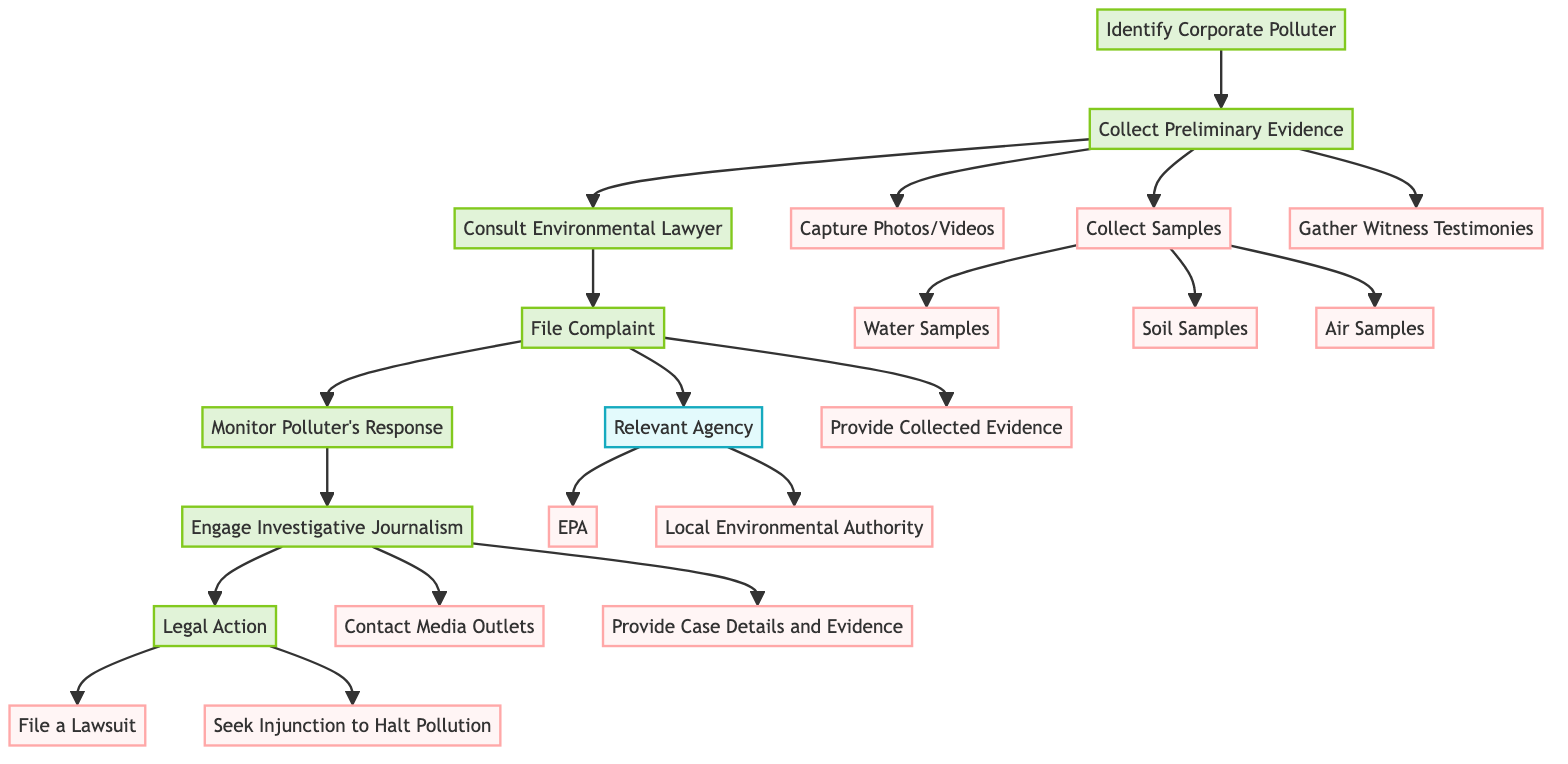What is the first step in the process? The first step, as depicted in the diagram, is "Identify the Corporate Polluter." This is the initial action that initiates the evidence collection process against corporate polluters.
Answer: Identify the Corporate Polluter How many sub-elements are under "Collect Preliminary Evidence"? The "Collect Preliminary Evidence" node has three sub-elements listed below it: "Capture Photos or Videos," "Collect Samples," and "Gather Witness Testimonies." Therefore, there are three sub-elements.
Answer: 3 What types of samples are collected? Within the "Collect Samples" sub-element, three types are specified: "Water Samples," "Soil Samples," and "Air Samples." These are the specific samples identified in the process.
Answer: Water Samples, Soil Samples, Air Samples What follows "Consult Environmental Lawyer"? The subsequent step that follows "Consult Environmental Lawyer" is "File a Complaint." The flow indicates that this is the next action after consulting a lawyer regarding the evidence collected against the polluter.
Answer: File a Complaint How many options are provided under "Relevant Agency"? The "Relevant Agency" sub-element includes two options: "Environmental Protection Agency (EPA)" and "Local Environmental Authority." Thus, there are two distinct agencies mentioned.
Answer: 2 What should happen after filing a complaint? Following the action of filing a complaint, the process indicates that one should "Monitor Polluter’s Response." This is the immediate next step after submitting a complaint to the relevant agency.
Answer: Monitor Polluter’s Response Which node leads to "Legal Action"? The node that leads to "Legal Action" is "Engage Investigative Journalism." The diagram shows a flow where engaging with journalism is a step before pursuing any legal action against the corporate polluter.
Answer: Engage Investigative Journalism What actions are included in "Legal Action"? The "Legal Action" node contains two actions: "File a Lawsuit" and "Seek Injunction to Halt Pollution." These represent the legal measures that can be taken after gathering evidence and other preceding steps.
Answer: File a Lawsuit, Seek Injunction to Halt Pollution 